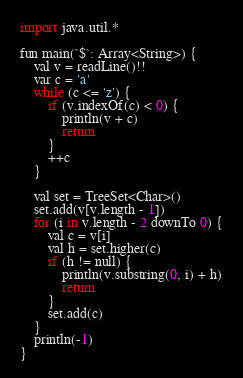Convert code to text. <code><loc_0><loc_0><loc_500><loc_500><_Python_>import java.util.*

fun main(`$`: Array<String>) {
    val v = readLine()!!
    var c = 'a'
    while (c <= 'z') {
        if (v.indexOf(c) < 0) {
            println(v + c)
            return
        }
        ++c
    }

    val set = TreeSet<Char>()
    set.add(v[v.length - 1])
    for (i in v.length - 2 downTo 0) {
        val c = v[i]
        val h = set.higher(c)
        if (h != null) {
            println(v.substring(0, i) + h)
            return
        }
        set.add(c)
    }
    println(-1)
}
</code> 